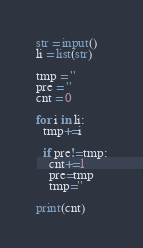Convert code to text. <code><loc_0><loc_0><loc_500><loc_500><_Python_>str = input()
li = list(str)

tmp = ''
pre = ''
cnt = 0

for i in li:
  tmp+=i

  if pre!=tmp:
    cnt+=1
    pre=tmp
    tmp=''

print(cnt)</code> 